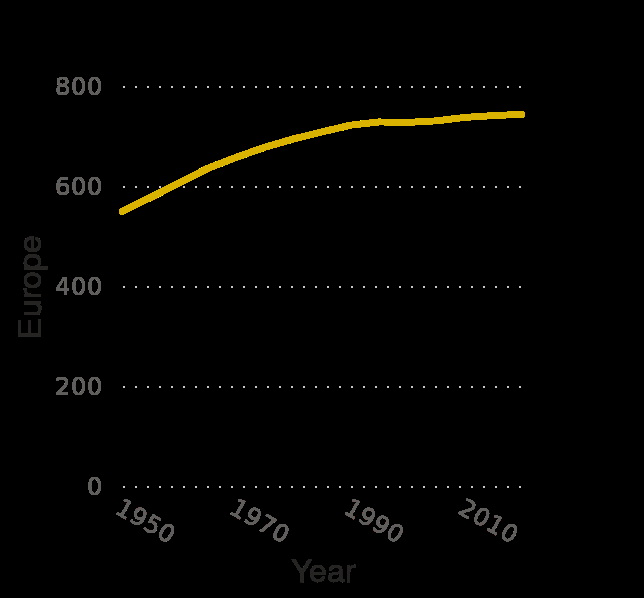<image>
Is the population growth depicted on the graph constant throughout the years?  Yes, the graph shows a steady incline in population growth from 1950 to 2010. What period does the graph cover?  The graph covers the period from 1950 to 2010. Does the graph provide specific data points for each year? No, the graph does not provide specific data points for each year; it only shows a general trend of population growth over time. 